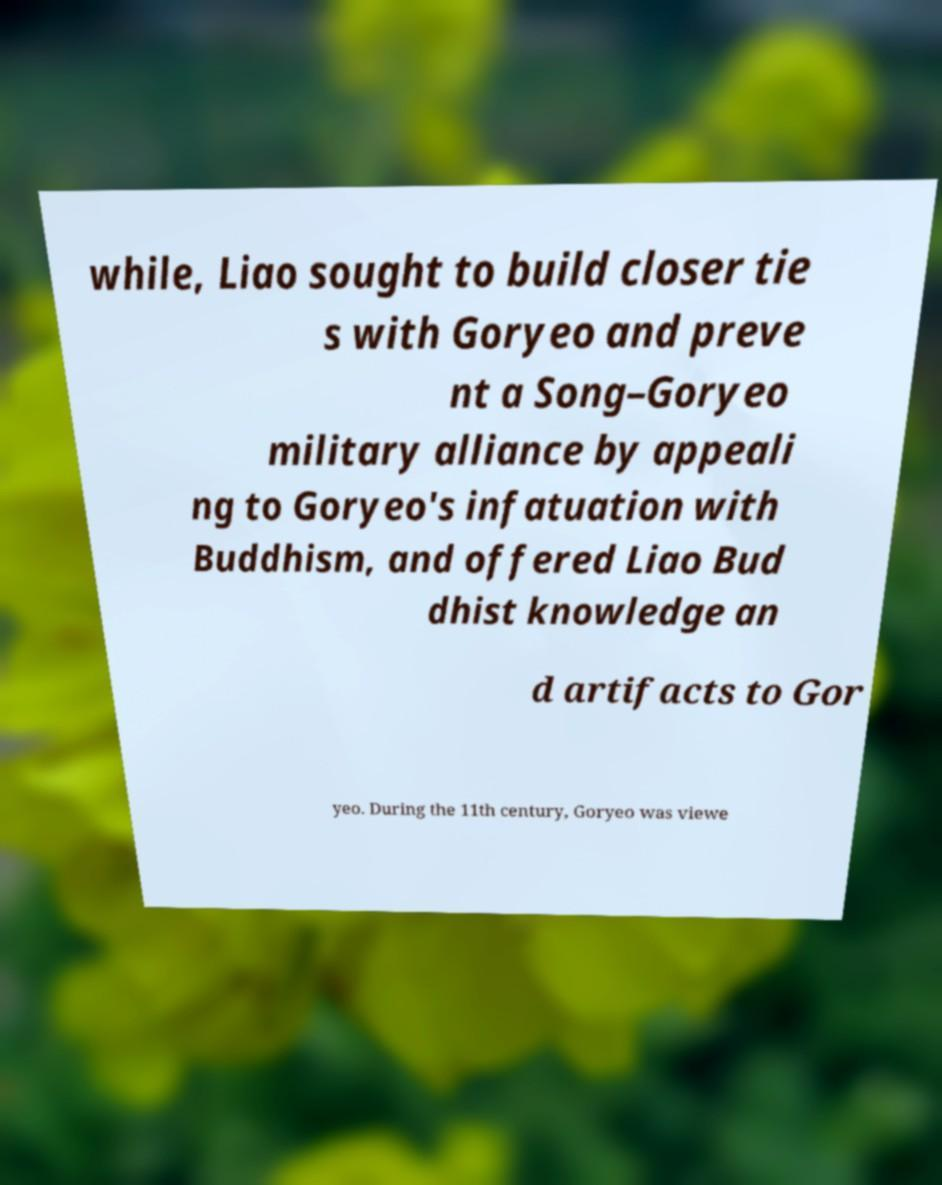Please read and relay the text visible in this image. What does it say? while, Liao sought to build closer tie s with Goryeo and preve nt a Song–Goryeo military alliance by appeali ng to Goryeo's infatuation with Buddhism, and offered Liao Bud dhist knowledge an d artifacts to Gor yeo. During the 11th century, Goryeo was viewe 